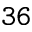Convert formula to latex. <formula><loc_0><loc_0><loc_500><loc_500>3 6</formula> 